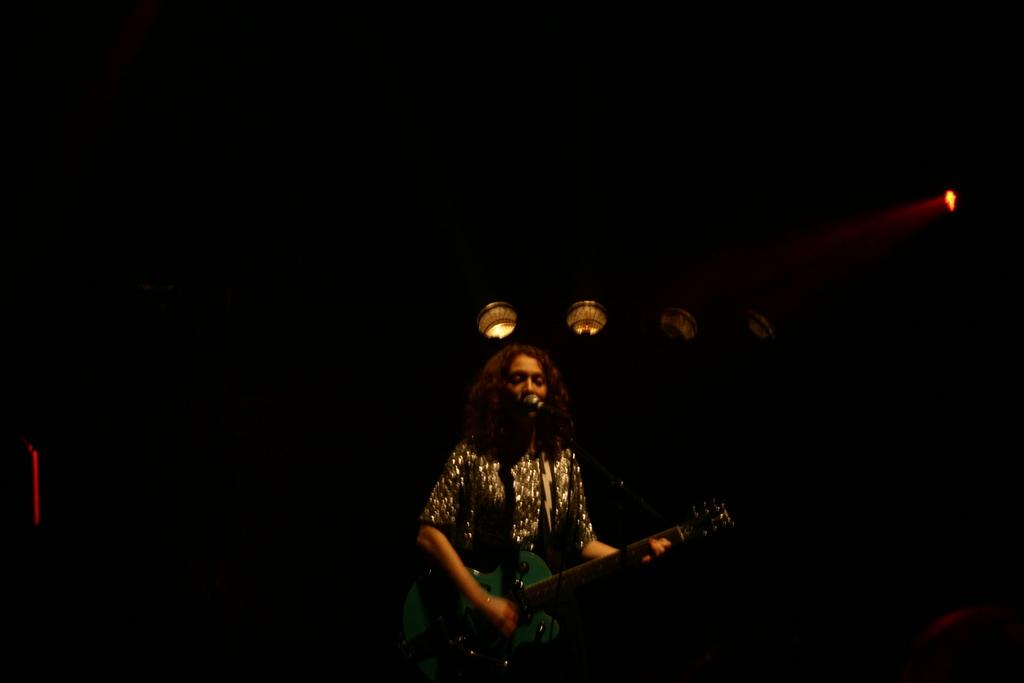Who is the main subject in the foreground of the image? There is a woman in the foreground of the image. What is the woman doing in the image? The woman is standing in front of a mic and playing a guitar. What can be seen in the background of the image? There are lights in the background of the image, and the background is dark. What type of honey is being used by the birds in the image? There are no birds or honey present in the image; it features a woman playing a guitar in front of a mic. 